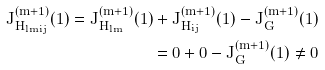Convert formula to latex. <formula><loc_0><loc_0><loc_500><loc_500>J ^ { ( m + 1 ) } _ { H _ { l m i j } } ( 1 ) = J ^ { ( m + 1 ) } _ { H _ { l m } } ( 1 ) + J ^ { ( m + 1 ) } _ { H _ { i j } } ( 1 ) - J ^ { ( m + 1 ) } _ { G } ( 1 ) \\ = 0 + 0 - J ^ { ( m + 1 ) } _ { G } ( 1 ) \neq 0</formula> 